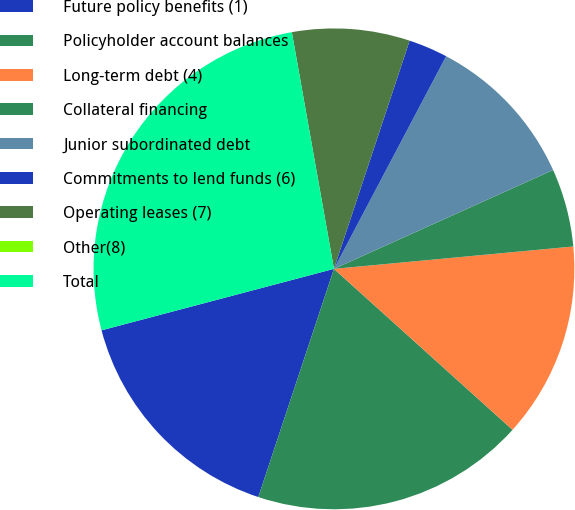Convert chart. <chart><loc_0><loc_0><loc_500><loc_500><pie_chart><fcel>Future policy benefits (1)<fcel>Policyholder account balances<fcel>Long-term debt (4)<fcel>Collateral financing<fcel>Junior subordinated debt<fcel>Commitments to lend funds (6)<fcel>Operating leases (7)<fcel>Other(8)<fcel>Total<nl><fcel>15.79%<fcel>18.42%<fcel>13.16%<fcel>5.26%<fcel>10.53%<fcel>2.63%<fcel>7.9%<fcel>0.0%<fcel>26.31%<nl></chart> 